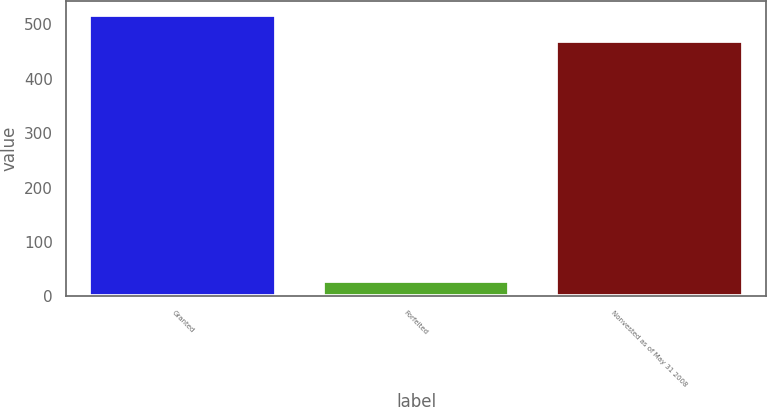<chart> <loc_0><loc_0><loc_500><loc_500><bar_chart><fcel>Granted<fcel>Forfeited<fcel>Nonvested as of May 31 2008<nl><fcel>517<fcel>29<fcel>470<nl></chart> 